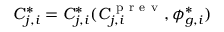<formula> <loc_0><loc_0><loc_500><loc_500>C _ { j , i } ^ { * } = C _ { j , i } ^ { * } ( C _ { j , i } ^ { p r e v } , \phi _ { g , i } ^ { * } )</formula> 